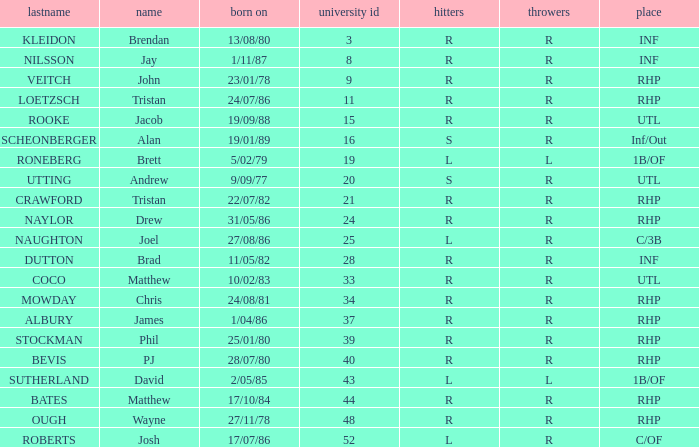Which Uni # has a Surname of ough? 48.0. 